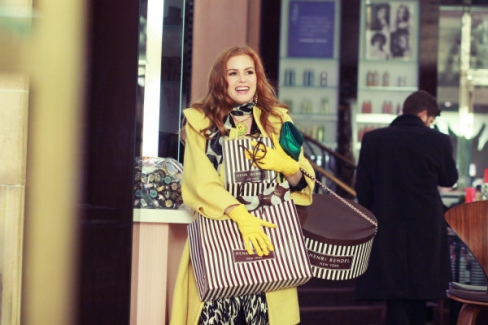Can you describe the style and color scheme of the outfit the woman is wearing? The woman is dressed in a striking yellow coat that stands out brightly against the urban backdrop. The coat's vibrant hue is complemented by her patterned dress underneath, which combines various colors harmoniously. She accessorizes with a green scarf and carries two large bags featuring bold stripes and geometric patterns, further adding to her eclectic and colorful style. 